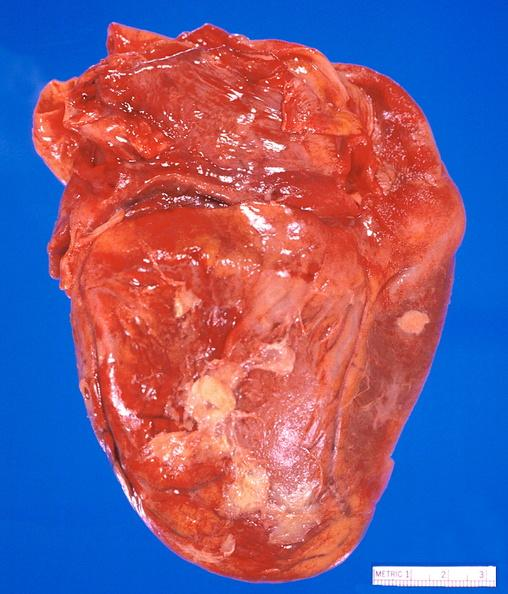what is present?
Answer the question using a single word or phrase. Cardiovascular 